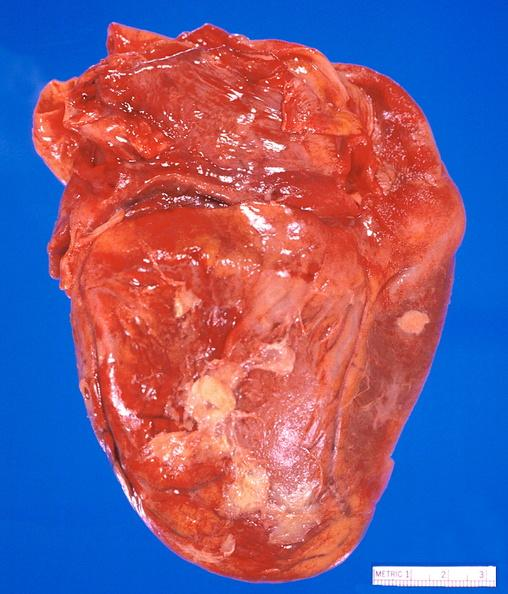what is present?
Answer the question using a single word or phrase. Cardiovascular 